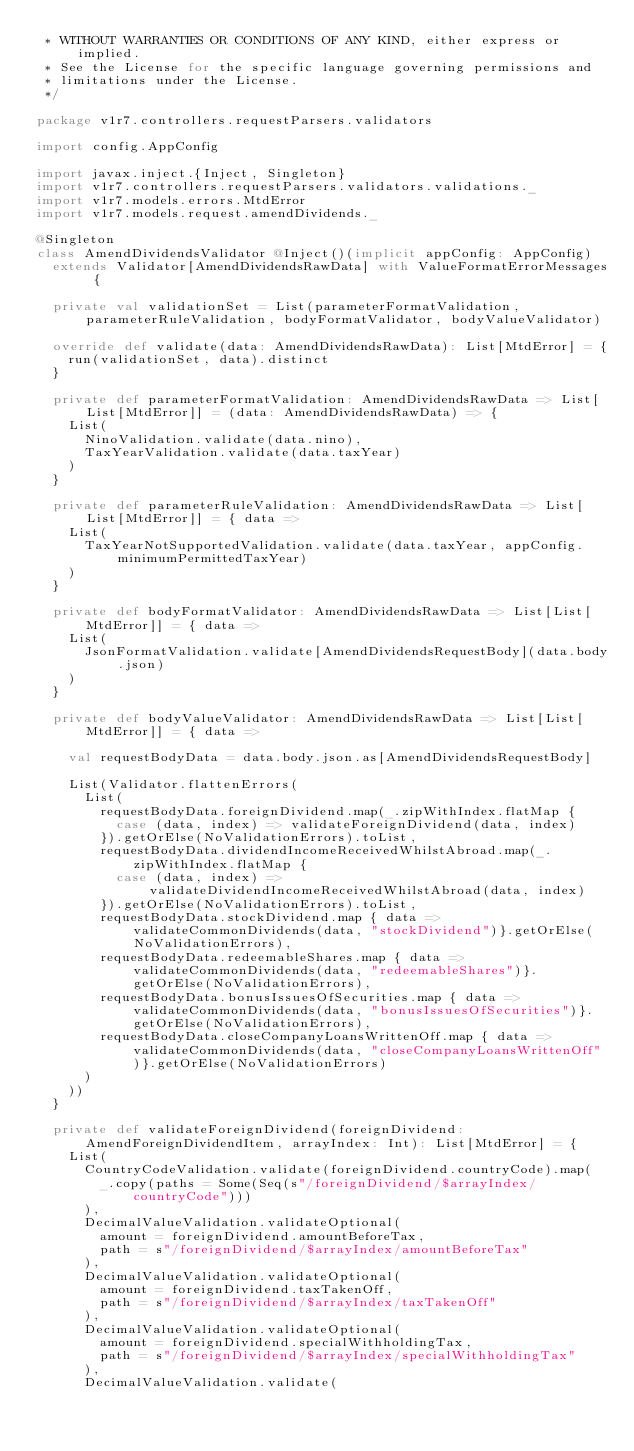Convert code to text. <code><loc_0><loc_0><loc_500><loc_500><_Scala_> * WITHOUT WARRANTIES OR CONDITIONS OF ANY KIND, either express or implied.
 * See the License for the specific language governing permissions and
 * limitations under the License.
 */

package v1r7.controllers.requestParsers.validators

import config.AppConfig

import javax.inject.{Inject, Singleton}
import v1r7.controllers.requestParsers.validators.validations._
import v1r7.models.errors.MtdError
import v1r7.models.request.amendDividends._

@Singleton
class AmendDividendsValidator @Inject()(implicit appConfig: AppConfig)
  extends Validator[AmendDividendsRawData] with ValueFormatErrorMessages {

  private val validationSet = List(parameterFormatValidation, parameterRuleValidation, bodyFormatValidator, bodyValueValidator)

  override def validate(data: AmendDividendsRawData): List[MtdError] = {
    run(validationSet, data).distinct
  }

  private def parameterFormatValidation: AmendDividendsRawData => List[List[MtdError]] = (data: AmendDividendsRawData) => {
    List(
      NinoValidation.validate(data.nino),
      TaxYearValidation.validate(data.taxYear)
    )
  }

  private def parameterRuleValidation: AmendDividendsRawData => List[List[MtdError]] = { data =>
    List(
      TaxYearNotSupportedValidation.validate(data.taxYear, appConfig.minimumPermittedTaxYear)
    )
  }

  private def bodyFormatValidator: AmendDividendsRawData => List[List[MtdError]] = { data =>
    List(
      JsonFormatValidation.validate[AmendDividendsRequestBody](data.body.json)
    )
  }

  private def bodyValueValidator: AmendDividendsRawData => List[List[MtdError]] = { data =>

    val requestBodyData = data.body.json.as[AmendDividendsRequestBody]

    List(Validator.flattenErrors(
      List(
        requestBodyData.foreignDividend.map(_.zipWithIndex.flatMap {
          case (data, index) => validateForeignDividend(data, index)
        }).getOrElse(NoValidationErrors).toList,
        requestBodyData.dividendIncomeReceivedWhilstAbroad.map(_.zipWithIndex.flatMap {
          case (data, index) => validateDividendIncomeReceivedWhilstAbroad(data, index)
        }).getOrElse(NoValidationErrors).toList,
        requestBodyData.stockDividend.map { data => validateCommonDividends(data, "stockDividend")}.getOrElse(NoValidationErrors),
        requestBodyData.redeemableShares.map { data => validateCommonDividends(data, "redeemableShares")}.getOrElse(NoValidationErrors),
        requestBodyData.bonusIssuesOfSecurities.map { data => validateCommonDividends(data, "bonusIssuesOfSecurities")}.getOrElse(NoValidationErrors),
        requestBodyData.closeCompanyLoansWrittenOff.map { data => validateCommonDividends(data, "closeCompanyLoansWrittenOff")}.getOrElse(NoValidationErrors)
      )
    ))
  }

  private def validateForeignDividend(foreignDividend: AmendForeignDividendItem, arrayIndex: Int): List[MtdError] = {
    List(
      CountryCodeValidation.validate(foreignDividend.countryCode).map(
        _.copy(paths = Some(Seq(s"/foreignDividend/$arrayIndex/countryCode")))
      ),
      DecimalValueValidation.validateOptional(
        amount = foreignDividend.amountBeforeTax,
        path = s"/foreignDividend/$arrayIndex/amountBeforeTax"
      ),
      DecimalValueValidation.validateOptional(
        amount = foreignDividend.taxTakenOff,
        path = s"/foreignDividend/$arrayIndex/taxTakenOff"
      ),
      DecimalValueValidation.validateOptional(
        amount = foreignDividend.specialWithholdingTax,
        path = s"/foreignDividend/$arrayIndex/specialWithholdingTax"
      ),
      DecimalValueValidation.validate(</code> 